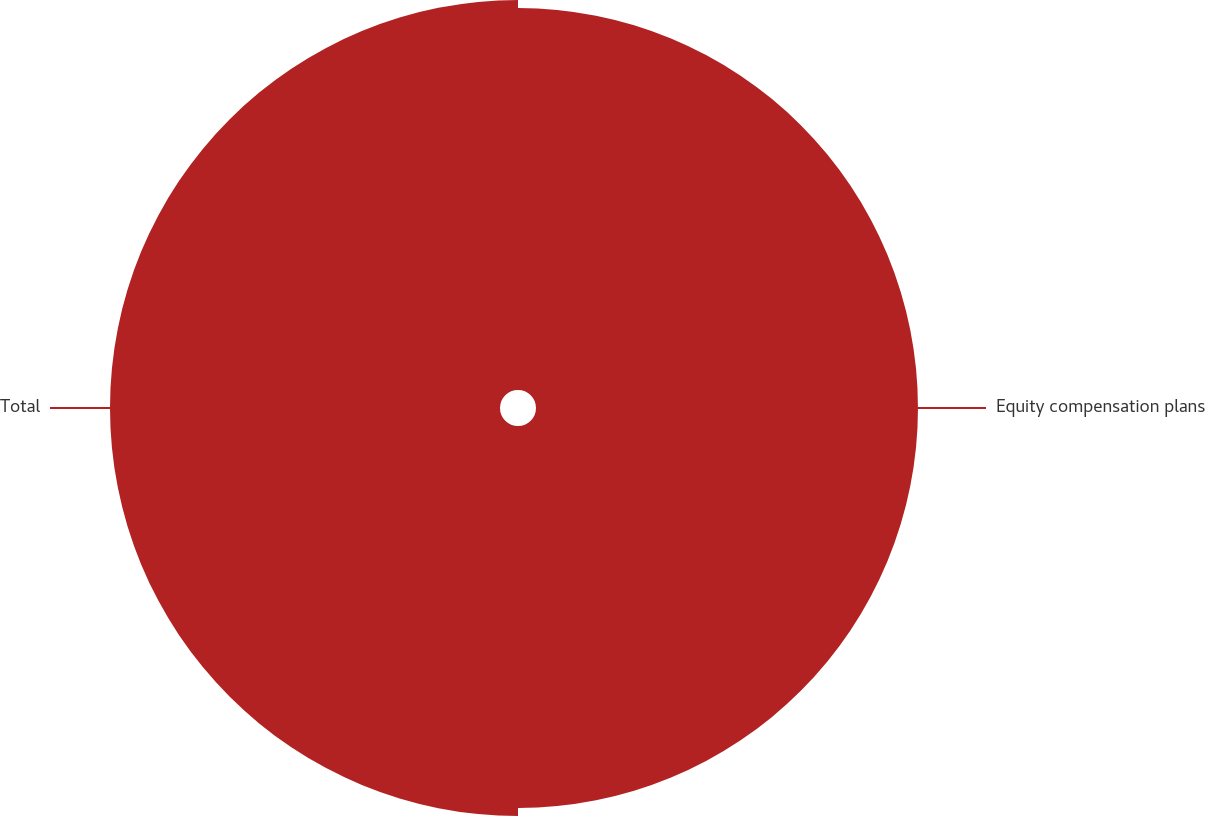Convert chart. <chart><loc_0><loc_0><loc_500><loc_500><pie_chart><fcel>Equity compensation plans<fcel>Total<nl><fcel>49.48%<fcel>50.52%<nl></chart> 